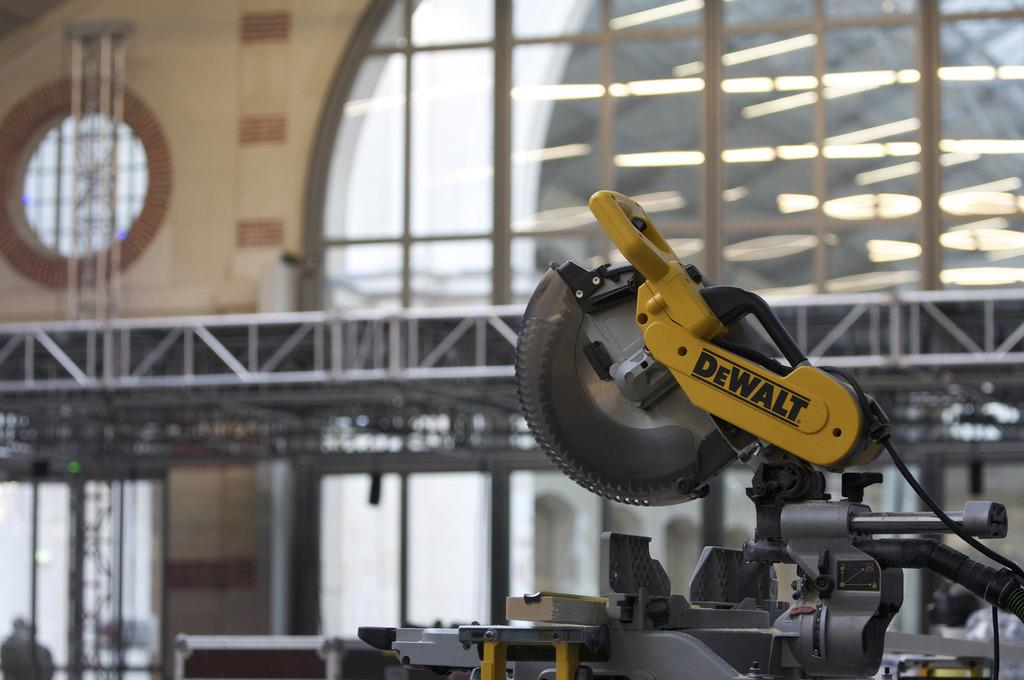<image>
Share a concise interpretation of the image provided. DeWALT tool inside a building with large glass windows. 